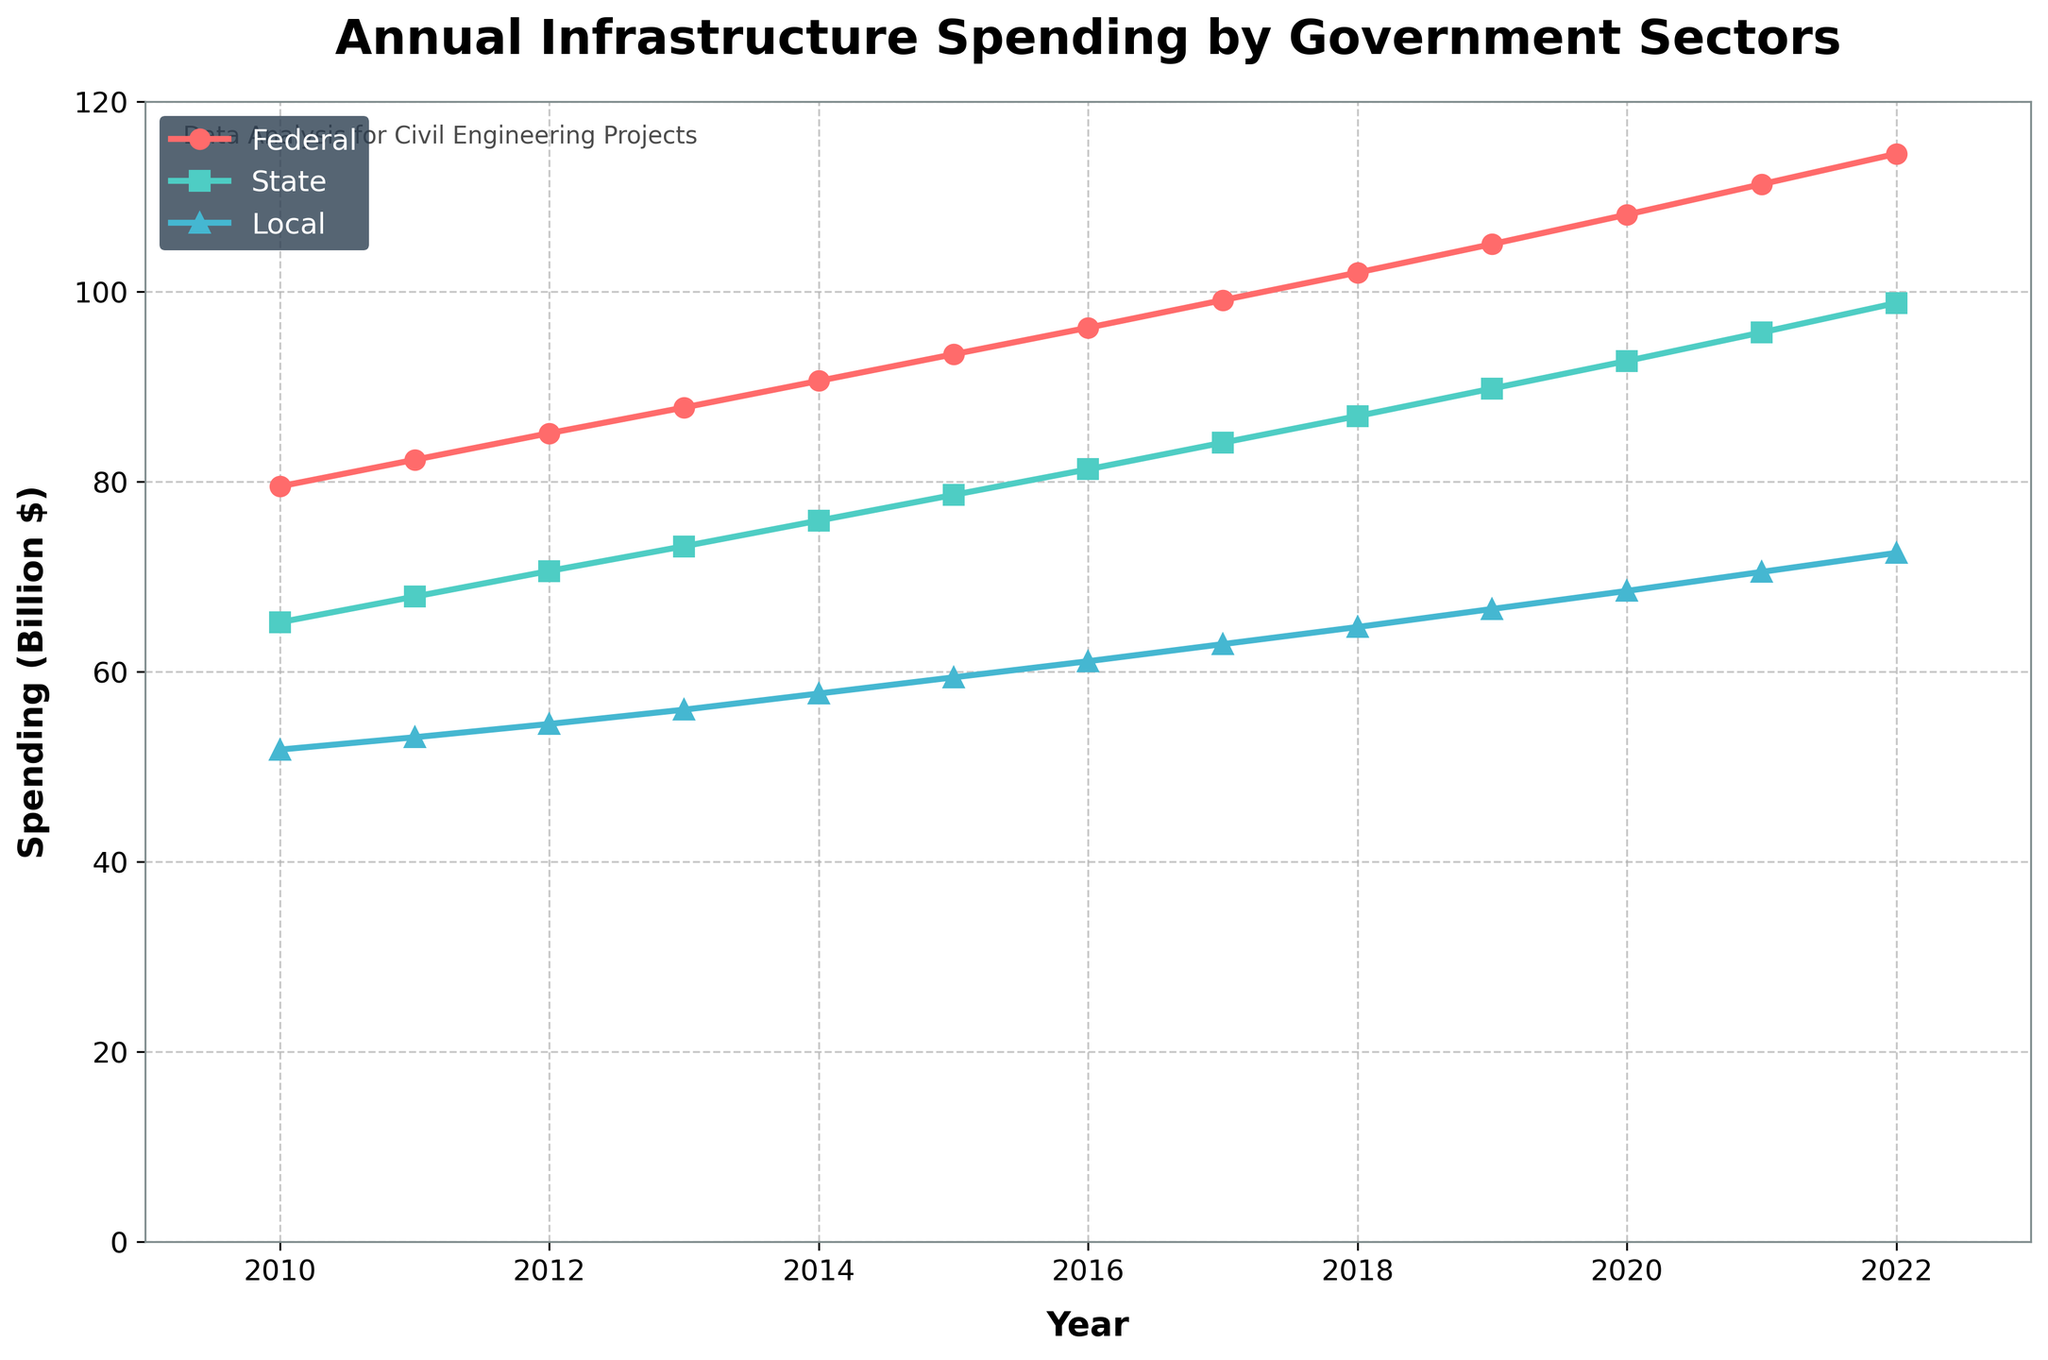What is the total infrastructure spending by the federal sector from 2010 to 2022? To find the total federal spending, sum up all the federal spending values from 2010 to 2022. (79.5 + 82.3 + 85.1 + 87.8 + 90.6 + 93.4 + 96.2 + 99.1 + 102.0 + 105.0 + 108.1 + 111.3 + 114.5) = 1255.9
Answer: 1255.9 billion $ Which year had the highest total infrastructure spending among all sectors? Look for the peak values of the combined spending of federal, state, and local for each year and identify the highest one. 2022 had the highest total combined spending (114.5 + 98.8 + 72.5 = 285.8). Hence, 2022 had the highest total spending.
Answer: 2022 In 2020, how much more did the federal government spend compared to the local government? Find the difference between federal and local spending in 2020. Federal spent 108.1 billion $ and Local spent 68.5 billion $. So, the difference = 108.1 - 68.5 = 39.6 billion $.
Answer: 39.6 billion $ Which government sector consistently increased its spending every year from 2010 to 2022? Evaluate the trends of each sector (federal, state, local) over the years. All sectors increase every year, but notably, the federal sector consistently shows no decrease or plateau.
Answer: Federal What was the average annual state spending from 2010 to 2022? To calculate the average, sum up the state spending values and divide by the number of years. (65.2 + 67.9 + 70.6 + 73.2 + 75.9 + 78.6 + 81.3 + 84.1 + 86.9 + 89.8 + 92.7 + 95.7 + 98.8) / 13 = 79.6
Answer: 79.6 billion $ Between 2015 and 2020, which sector had the highest increase in spending? Calculate the difference in spending for each sector between 2015 and 2020 and identify the highest. Federal: 108.1 - 93.4 = 14.7; State: 92.7 - 78.6 = 14.1; Local: 68.5 - 59.4 = 9.1. Federal had the highest increase.
Answer: Federal Compare the spending of the state and local sectors in 2013. Which one is higher and by how much? State spending in 2013 is 73.2 billion $, and local is 56.0 billion $. The difference is 73.2 - 56.0 = 17.2 billion $, with state spending more.
Answer: State by 17.2 billion $ What year did the local government first spend over 60 billion $ on infrastructure? Observe the local spending line and identify the first year it crossed 60 billion $. The data shows that year is 2016.
Answer: 2016 Which sector had the slowest rate of increase in spending from 2010 to 2022? Calculate the difference between the starting and ending spending for each sector over the years to determine the slowest increase. Federal: 114.5 - 79.5 = 35.0; State: 98.8 - 65.2 = 33.6; Local: 72.5 - 51.8 = 20.7. Local had the slowest increase.
Answer: Local 